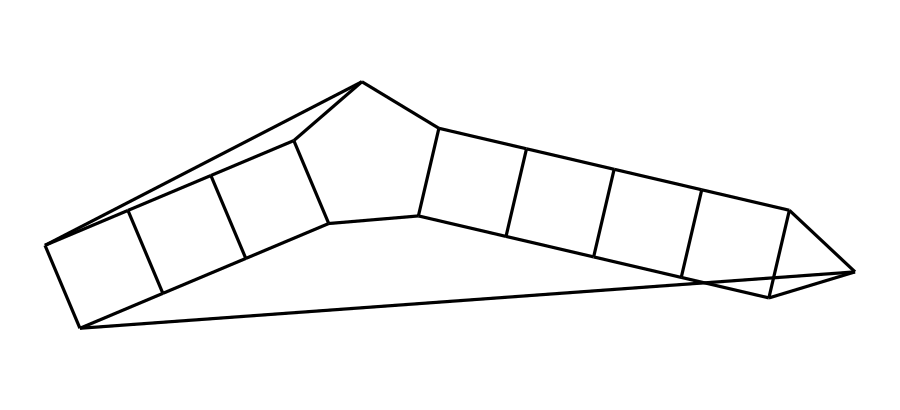How many carbon atoms are in dodecahedrane? The SMILES representation indicates 12 carbon atoms based on the 'C' symbols present in the string. Each 'C' represents a carbon atom in the structure.
Answer: 12 What is the molecular formula of dodecahedrane? Dodecahedrane has 12 carbon atoms and 24 hydrogen atoms, leading to the molecular formula C12H24, inferred from the structure where each carbon is typically bonded to enough hydrogen to satisfy carbon’s tetravalency.
Answer: C12H24 Is dodecahedrane a ring compound? The nature of dodecahedrane, indicated by its highly symmetrical cage-like structure, implies that it consists of interconnected carbon atoms forming a closed loop, thereby categorizing it as a ring compound.
Answer: Yes What symmetry does dodecahedrane exhibit? Dodecahedrane has a high degree of symmetry with icosahedral symmetry, as it can be visualized to have a shape similar to that of a dodecahedron, reflecting its even distribution of atoms.
Answer: Icosahedral What are potential applications of dodecahedrane? Its unique structural properties allow for applications such as energy-efficient insulation, as its cage-like nature can trap air, providing better thermal insulation characteristics compared to conventional materials.
Answer: Insulation What type of chemical compound is dodecahedrane classified as? Dodecahedrane is classified as a cage hydrocarbon due to its cage-like structure formed by carbon atoms, distinguishing it from linear and branched hydrocarbons.
Answer: Cage hydrocarbon Does dodecahedrane have single or double bonds? The structure of dodecahedrane consists solely of single C-C bonds, characteristic of saturated hydrocarbons, leading to increased stability and saturation.
Answer: Single bonds 